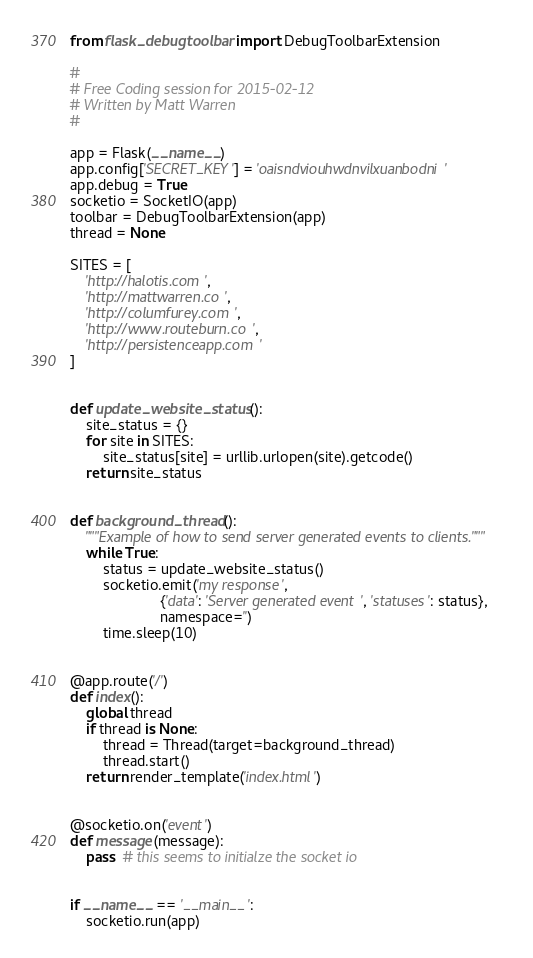<code> <loc_0><loc_0><loc_500><loc_500><_Python_>from flask_debugtoolbar import DebugToolbarExtension

#
# Free Coding session for 2015-02-12
# Written by Matt Warren
#

app = Flask(__name__)
app.config['SECRET_KEY'] = 'oaisndviouhwdnvilxuanbodni'
app.debug = True
socketio = SocketIO(app)
toolbar = DebugToolbarExtension(app)
thread = None

SITES = [
    'http://halotis.com',
    'http://mattwarren.co',
    'http://columfurey.com',
    'http://www.routeburn.co',
    'http://persistenceapp.com'
]


def update_website_status():
    site_status = {}
    for site in SITES:
        site_status[site] = urllib.urlopen(site).getcode()
    return site_status


def background_thread():
    """Example of how to send server generated events to clients."""
    while True:
        status = update_website_status()
        socketio.emit('my response',
                      {'data': 'Server generated event', 'statuses': status},
                      namespace='')
        time.sleep(10)


@app.route('/')
def index():
    global thread
    if thread is None:
        thread = Thread(target=background_thread)
        thread.start()
    return render_template('index.html')


@socketio.on('event')
def message(message):
    pass  # this seems to initialze the socket io


if __name__ == '__main__':
    socketio.run(app)
</code> 